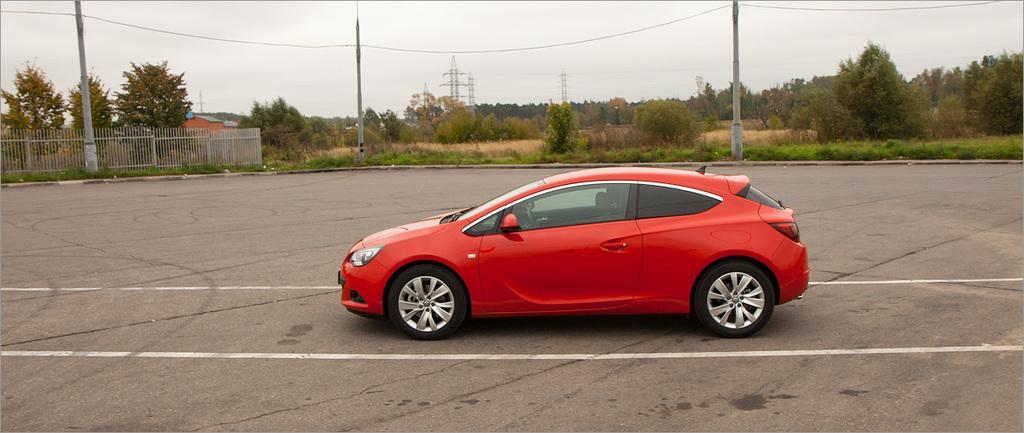Where was the image taken? The image is clicked outside. What can be seen in the middle of the image? There are trees and poles in the middle of the image. What is visible at the top of the image? The sky is visible at the top of the image. What type of vehicle is present in the image? There is a red car in the middle of the image. How many bikes are hanging from the neck of the person in the image? There are no bikes or people present in the image, so this question cannot be answered. 